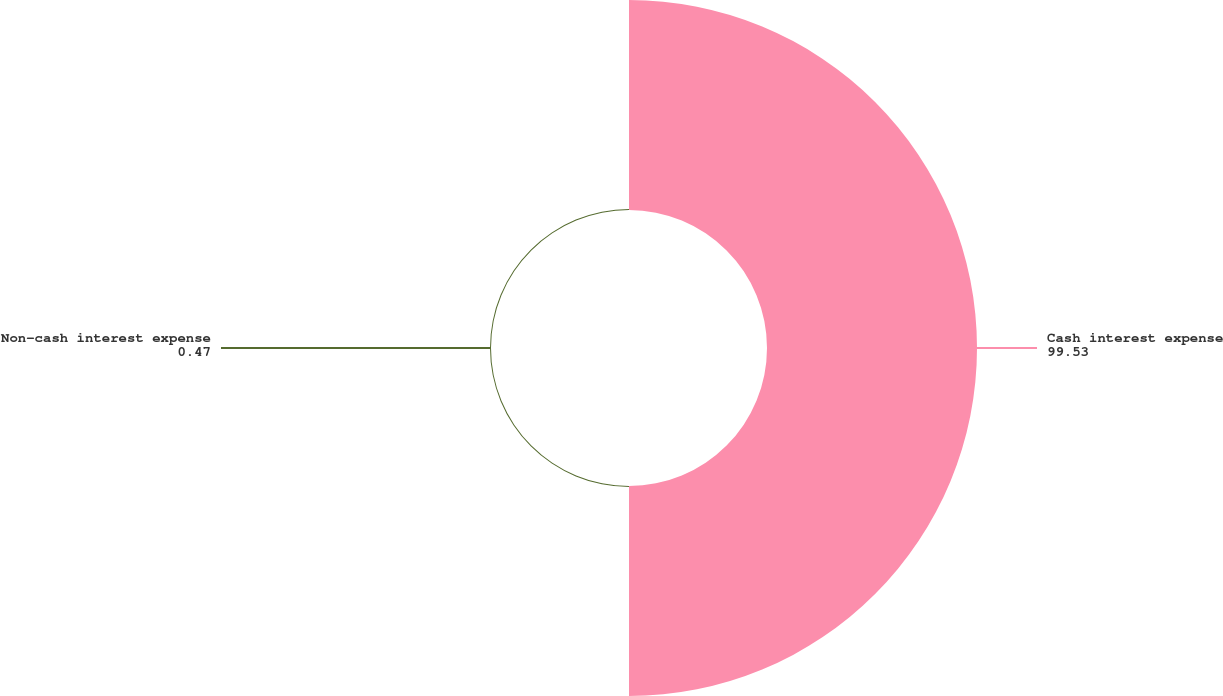Convert chart to OTSL. <chart><loc_0><loc_0><loc_500><loc_500><pie_chart><fcel>Cash interest expense<fcel>Non-cash interest expense<nl><fcel>99.53%<fcel>0.47%<nl></chart> 